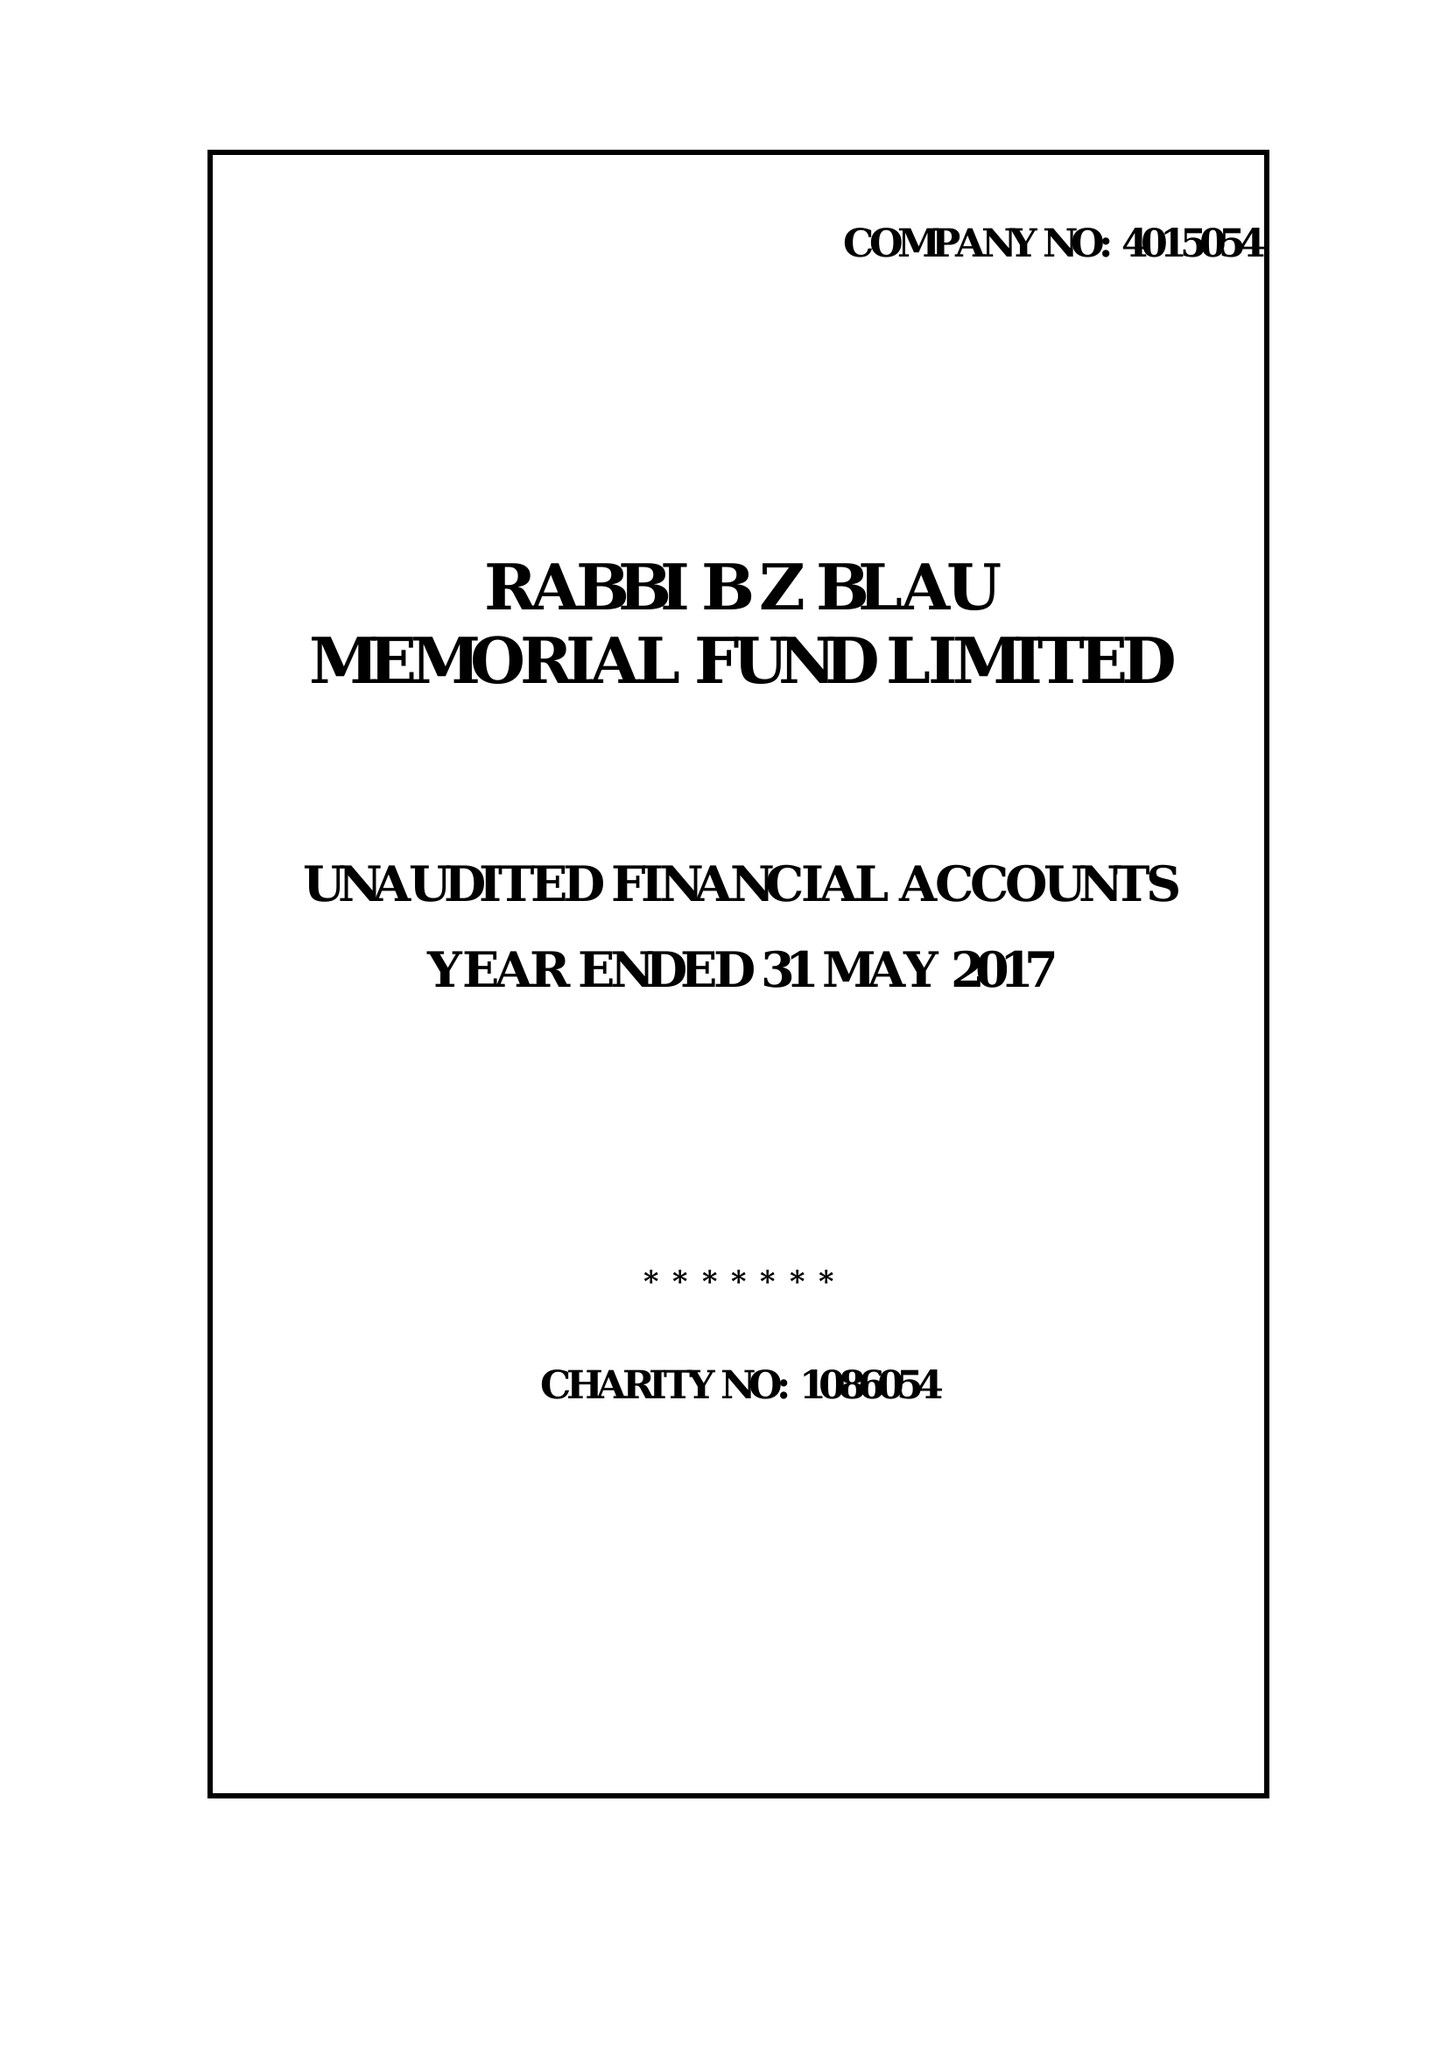What is the value for the address__street_line?
Answer the question using a single word or phrase. 11C GROSVENOR WAY 